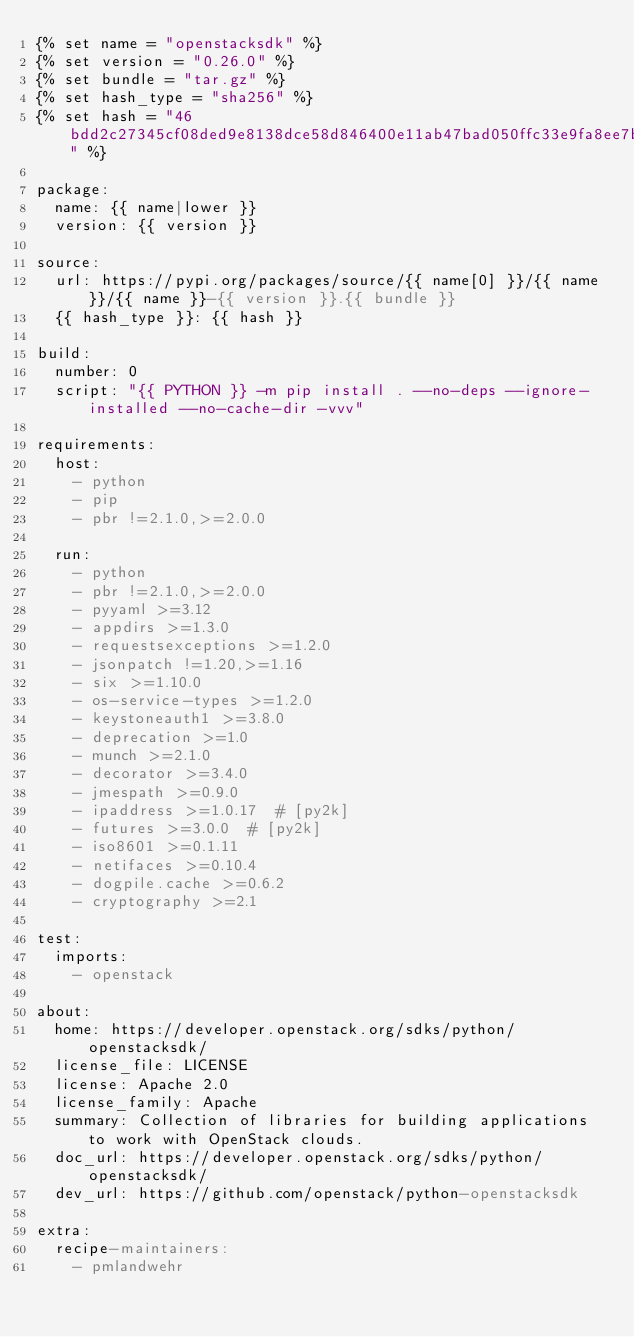Convert code to text. <code><loc_0><loc_0><loc_500><loc_500><_YAML_>{% set name = "openstacksdk" %}
{% set version = "0.26.0" %}
{% set bundle = "tar.gz" %}
{% set hash_type = "sha256" %}
{% set hash = "46bdd2c27345cf08ded9e8138dce58d846400e11ab47bad050ffc33e9fa8ee7b" %}

package:
  name: {{ name|lower }}
  version: {{ version }}

source:
  url: https://pypi.org/packages/source/{{ name[0] }}/{{ name }}/{{ name }}-{{ version }}.{{ bundle }}
  {{ hash_type }}: {{ hash }}

build:
  number: 0
  script: "{{ PYTHON }} -m pip install . --no-deps --ignore-installed --no-cache-dir -vvv"

requirements:
  host:
    - python
    - pip
    - pbr !=2.1.0,>=2.0.0

  run:
    - python
    - pbr !=2.1.0,>=2.0.0
    - pyyaml >=3.12
    - appdirs >=1.3.0
    - requestsexceptions >=1.2.0
    - jsonpatch !=1.20,>=1.16
    - six >=1.10.0
    - os-service-types >=1.2.0
    - keystoneauth1 >=3.8.0
    - deprecation >=1.0
    - munch >=2.1.0
    - decorator >=3.4.0
    - jmespath >=0.9.0
    - ipaddress >=1.0.17  # [py2k]
    - futures >=3.0.0  # [py2k]
    - iso8601 >=0.1.11
    - netifaces >=0.10.4
    - dogpile.cache >=0.6.2
    - cryptography >=2.1

test:
  imports:
    - openstack

about:
  home: https://developer.openstack.org/sdks/python/openstacksdk/
  license_file: LICENSE
  license: Apache 2.0
  license_family: Apache
  summary: Collection of libraries for building applications to work with OpenStack clouds.
  doc_url: https://developer.openstack.org/sdks/python/openstacksdk/
  dev_url: https://github.com/openstack/python-openstacksdk

extra:
  recipe-maintainers:
    - pmlandwehr
</code> 